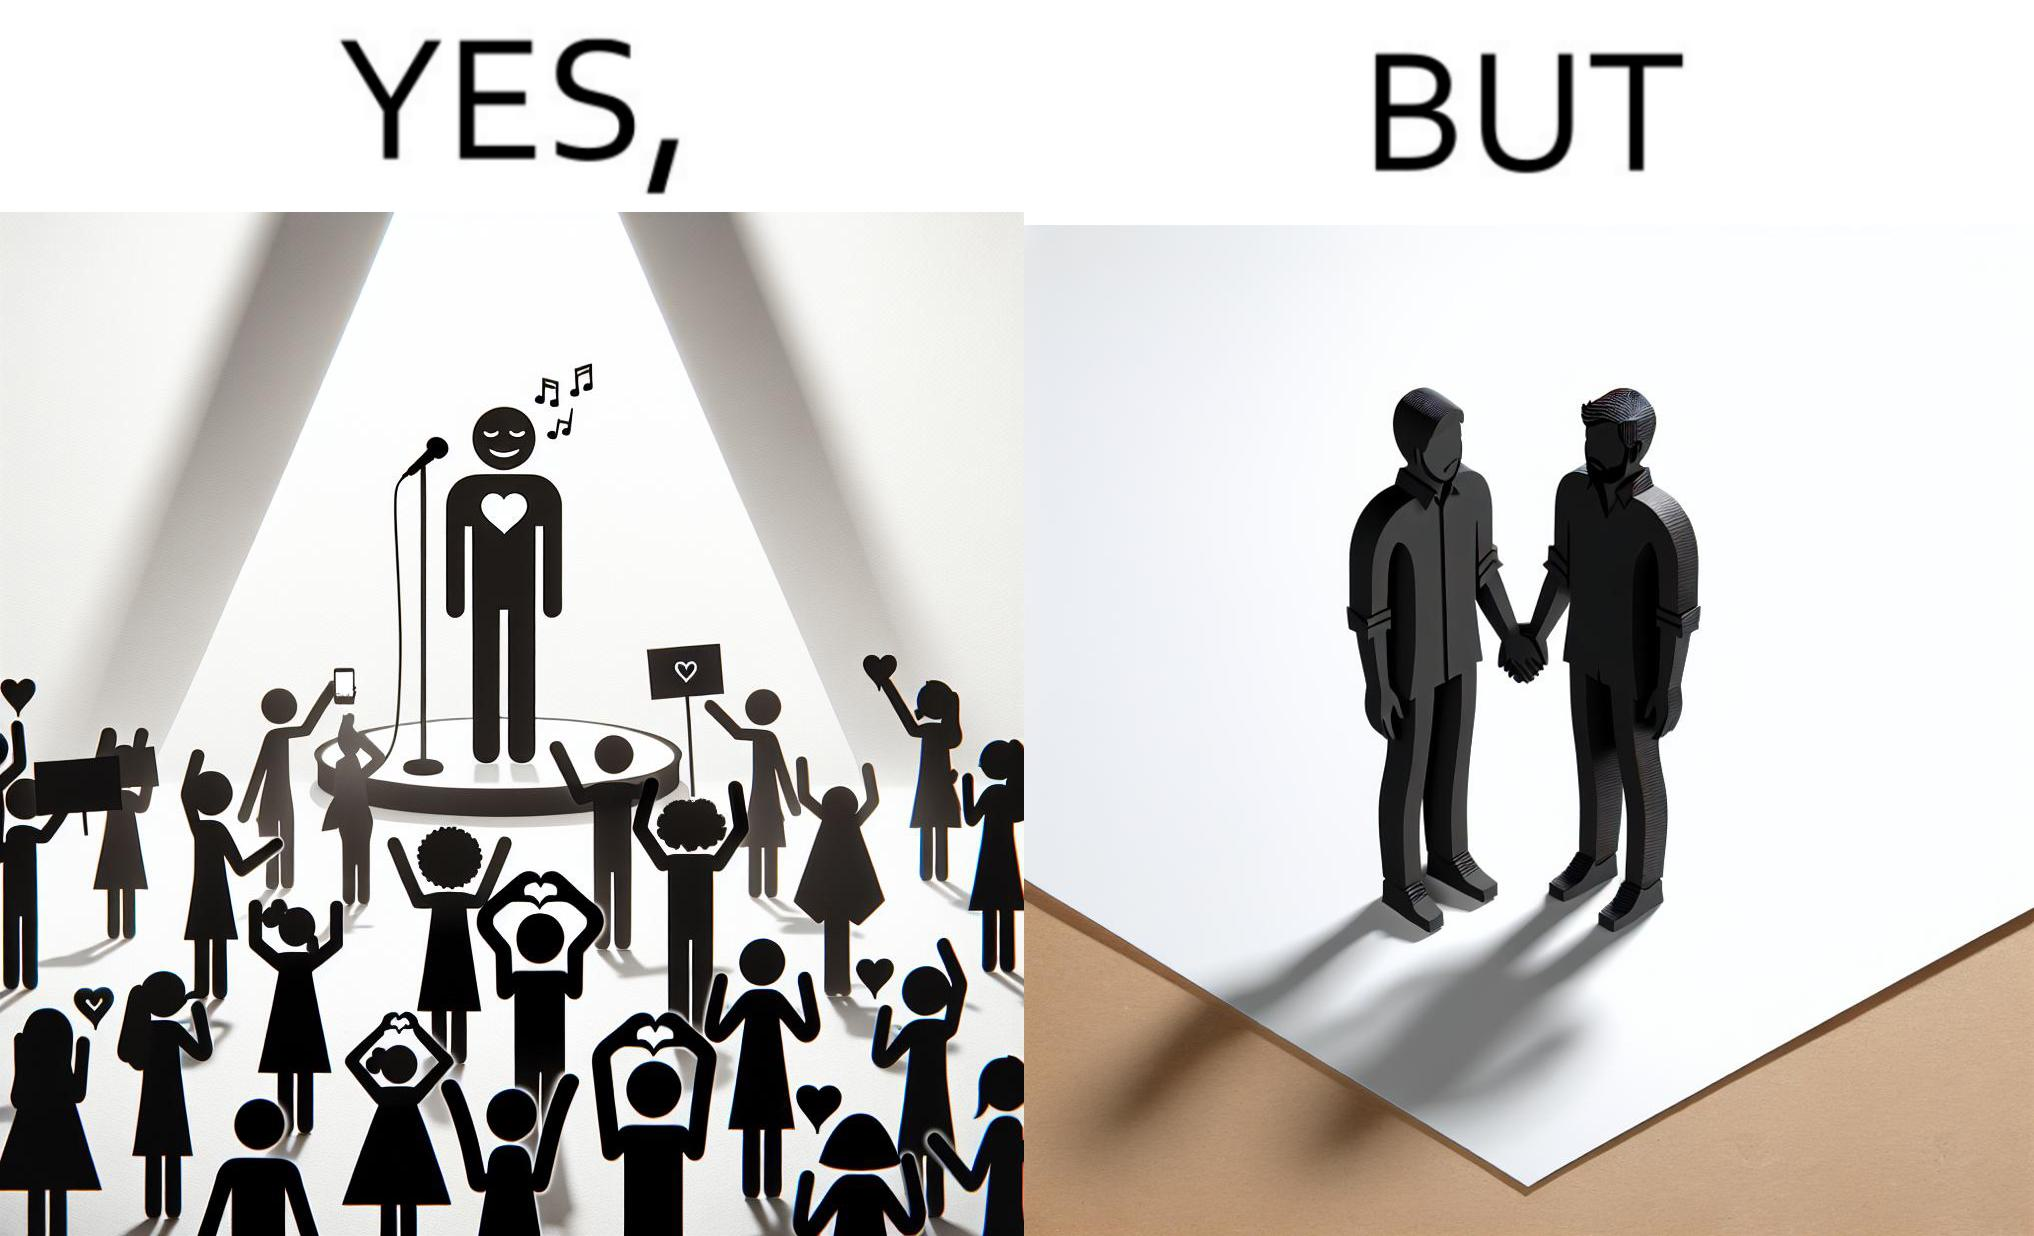What do you see in each half of this image? In the left part of the image: The person shows a man singing on a platform under a spotlight. There are several girls around the platform enjoying his singing and cheering for him. A few girls are taking his photos using their phone and a few also have a poster with heart drawn on it. In the right part of the image: The image shows two men holding hands. 